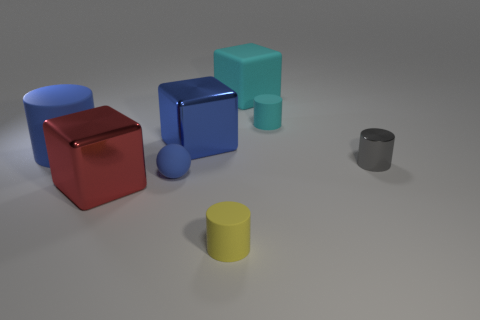Is there a thing?
Offer a terse response. Yes. What number of other objects are the same size as the yellow rubber thing?
Your response must be concise. 3. There is a large metallic block that is behind the red metal block; is its color the same as the rubber thing on the left side of the red block?
Your response must be concise. Yes. What is the size of the blue thing that is the same shape as the big cyan rubber thing?
Keep it short and to the point. Large. Is the material of the big object that is in front of the gray metallic object the same as the big blue block right of the large red metallic object?
Ensure brevity in your answer.  Yes. What number of metallic objects are either cyan cylinders or small yellow things?
Keep it short and to the point. 0. There is a tiny yellow cylinder that is in front of the cylinder to the left of the metal cube right of the sphere; what is its material?
Provide a short and direct response. Rubber. There is a shiny thing right of the blue cube; is it the same shape as the big blue metal object that is behind the tiny rubber ball?
Your response must be concise. No. What color is the matte cylinder in front of the large matte object that is in front of the big rubber cube?
Make the answer very short. Yellow. What number of cylinders are either tiny blue objects or blue objects?
Your response must be concise. 1. 